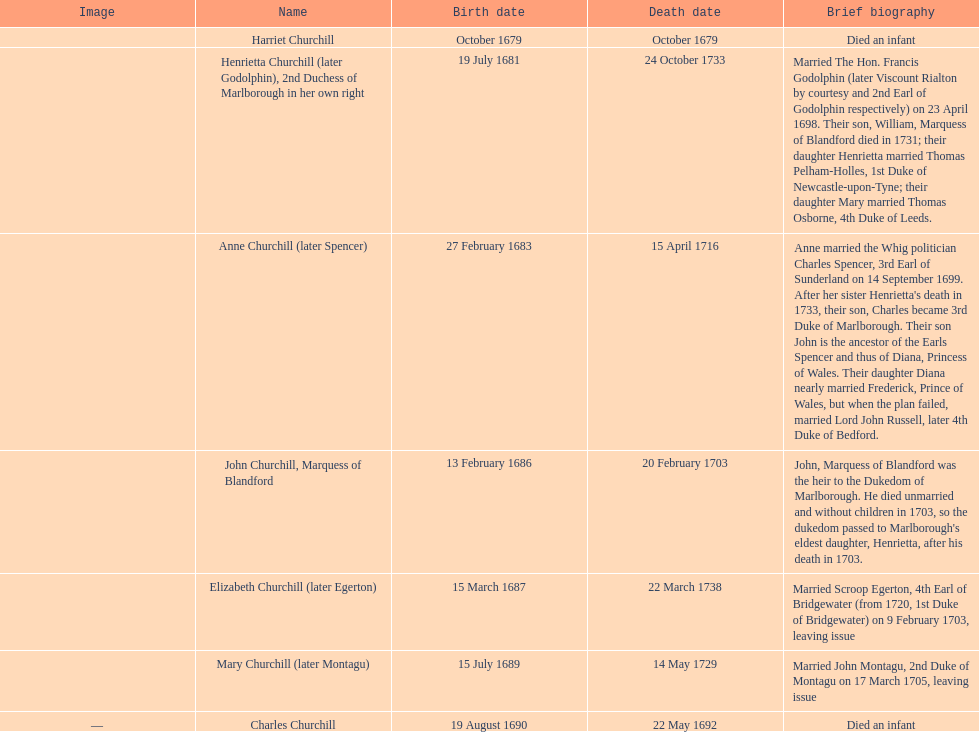How long did anne churchill/spencer live? 33. 